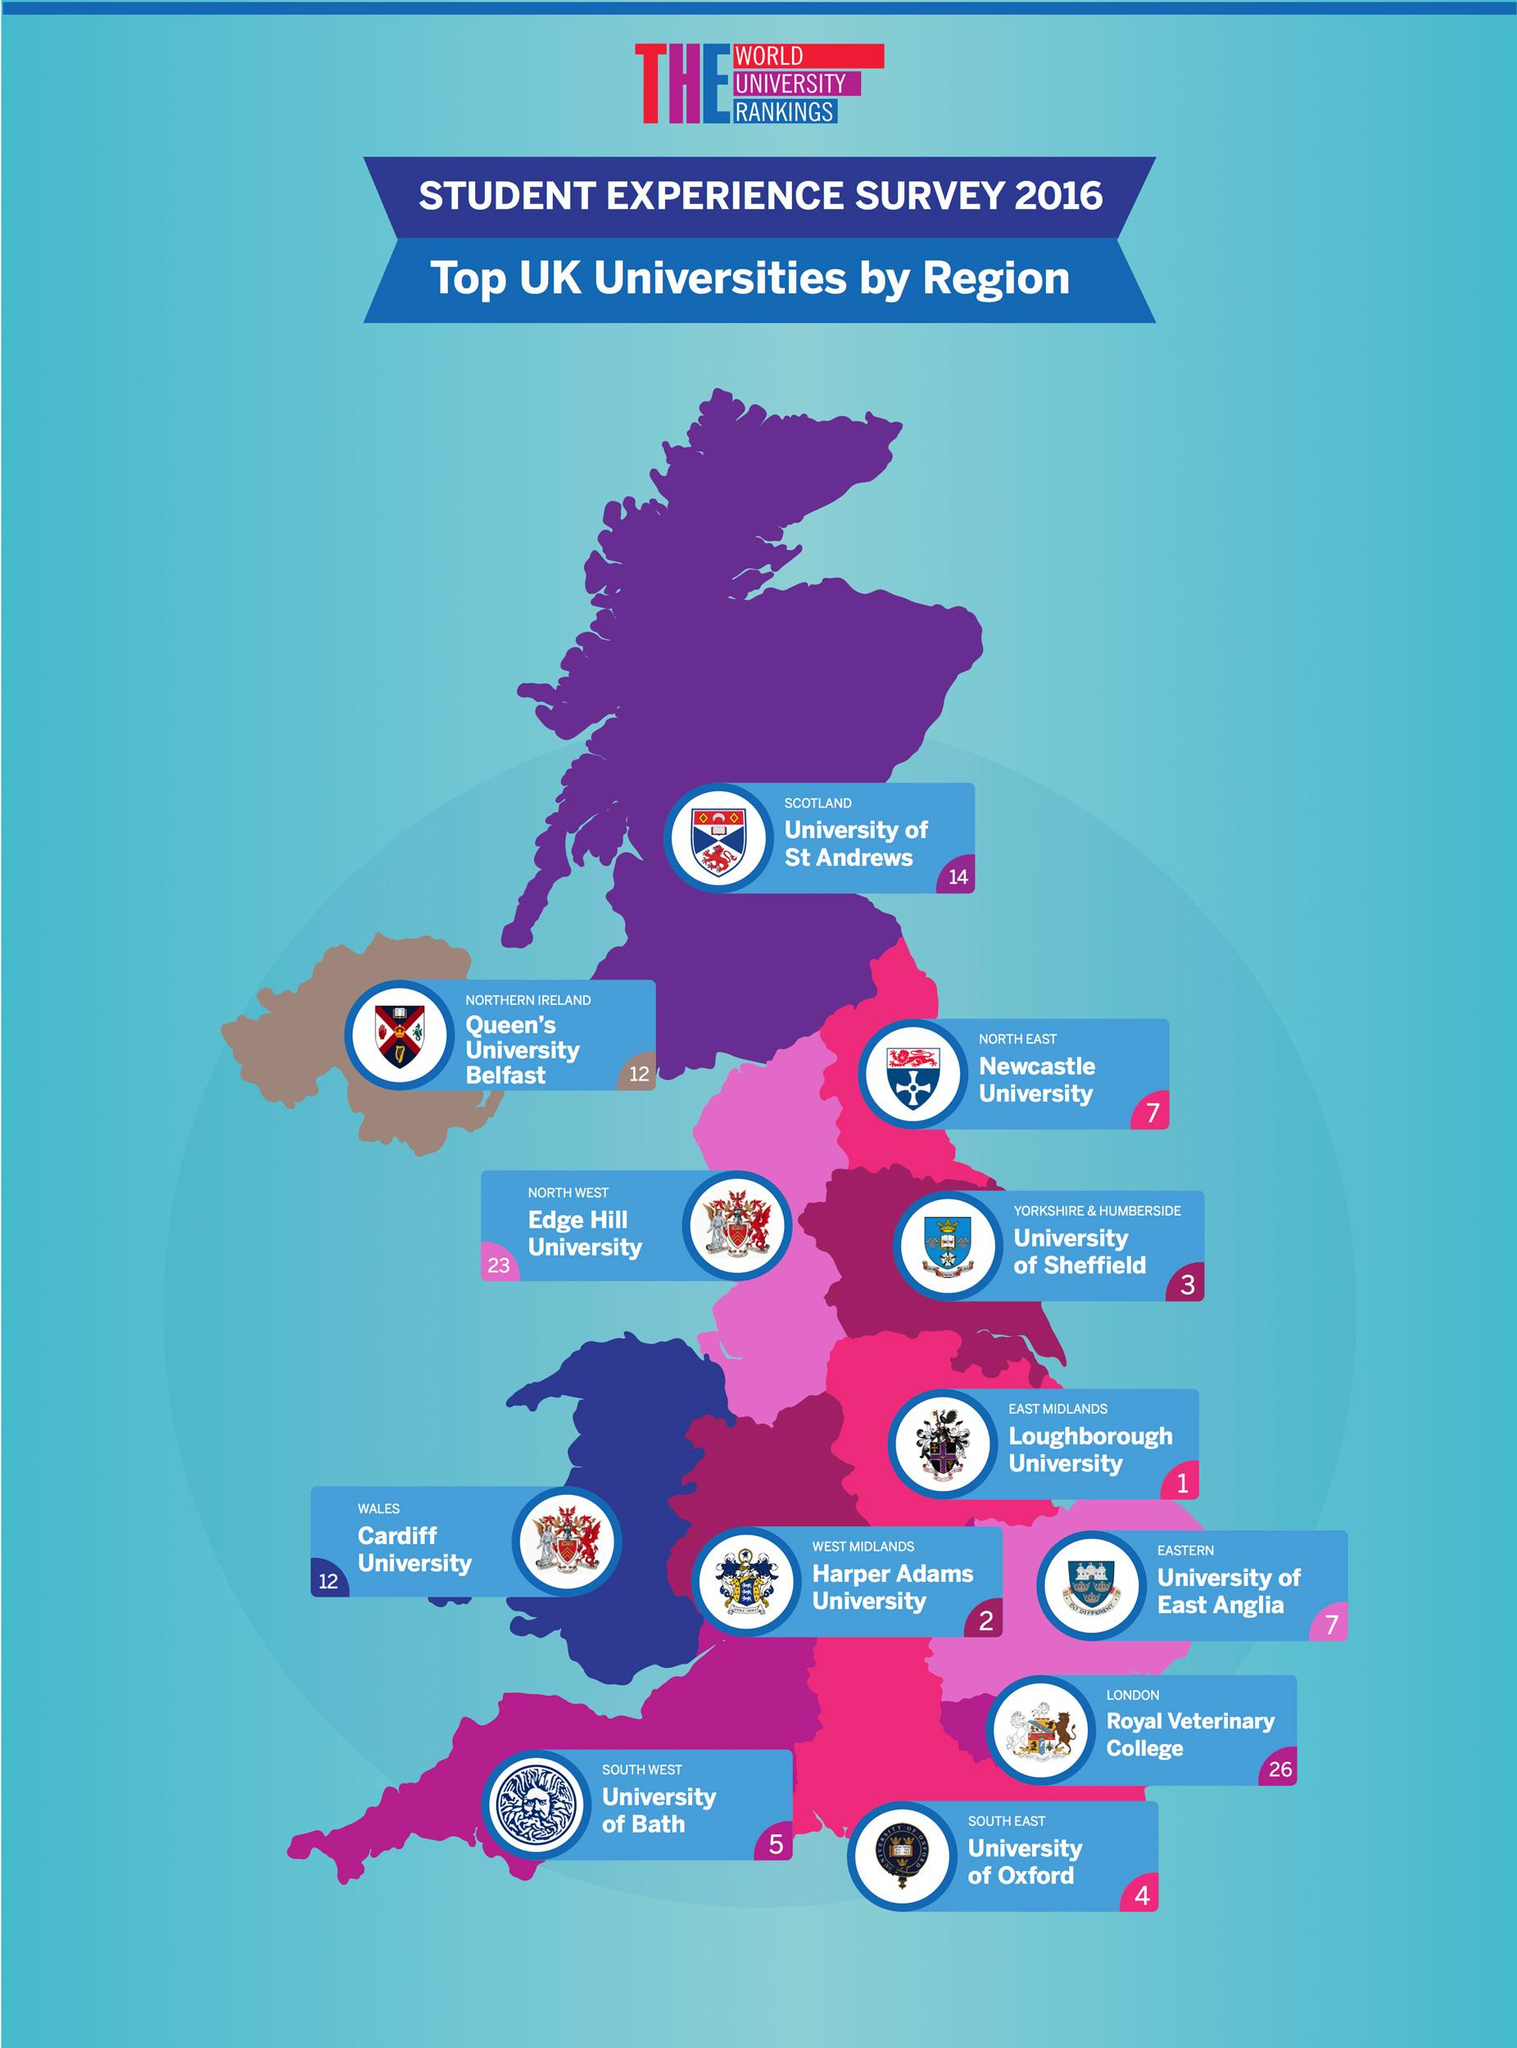Highlight a few significant elements in this photo. Edge Hill University is located in the North West region of the United Kingdom. According to the student experience survey conducted in 2016, Harper Adams University is ranked as the second best university in the UK. Queen's University Belfast is ranked as the top rated university in Northern Ireland based on the student experience survey conducted in 2016. According to the student experience survey conducted in 2016, Cardiff University is the top-rated university in Wales. The University of Sheffield is ranked as the third best UK university based on the student experience survey conducted in 2016. 